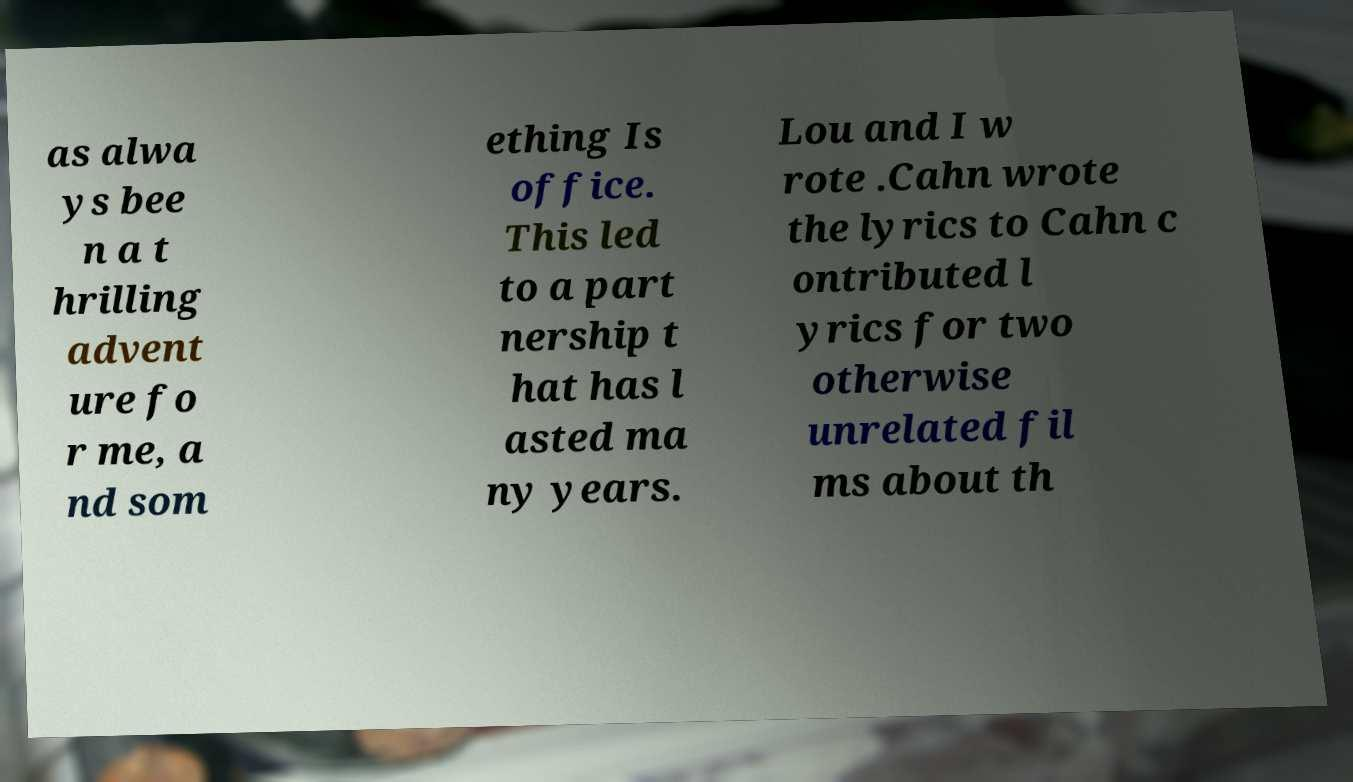I need the written content from this picture converted into text. Can you do that? as alwa ys bee n a t hrilling advent ure fo r me, a nd som ething Is office. This led to a part nership t hat has l asted ma ny years. Lou and I w rote .Cahn wrote the lyrics to Cahn c ontributed l yrics for two otherwise unrelated fil ms about th 